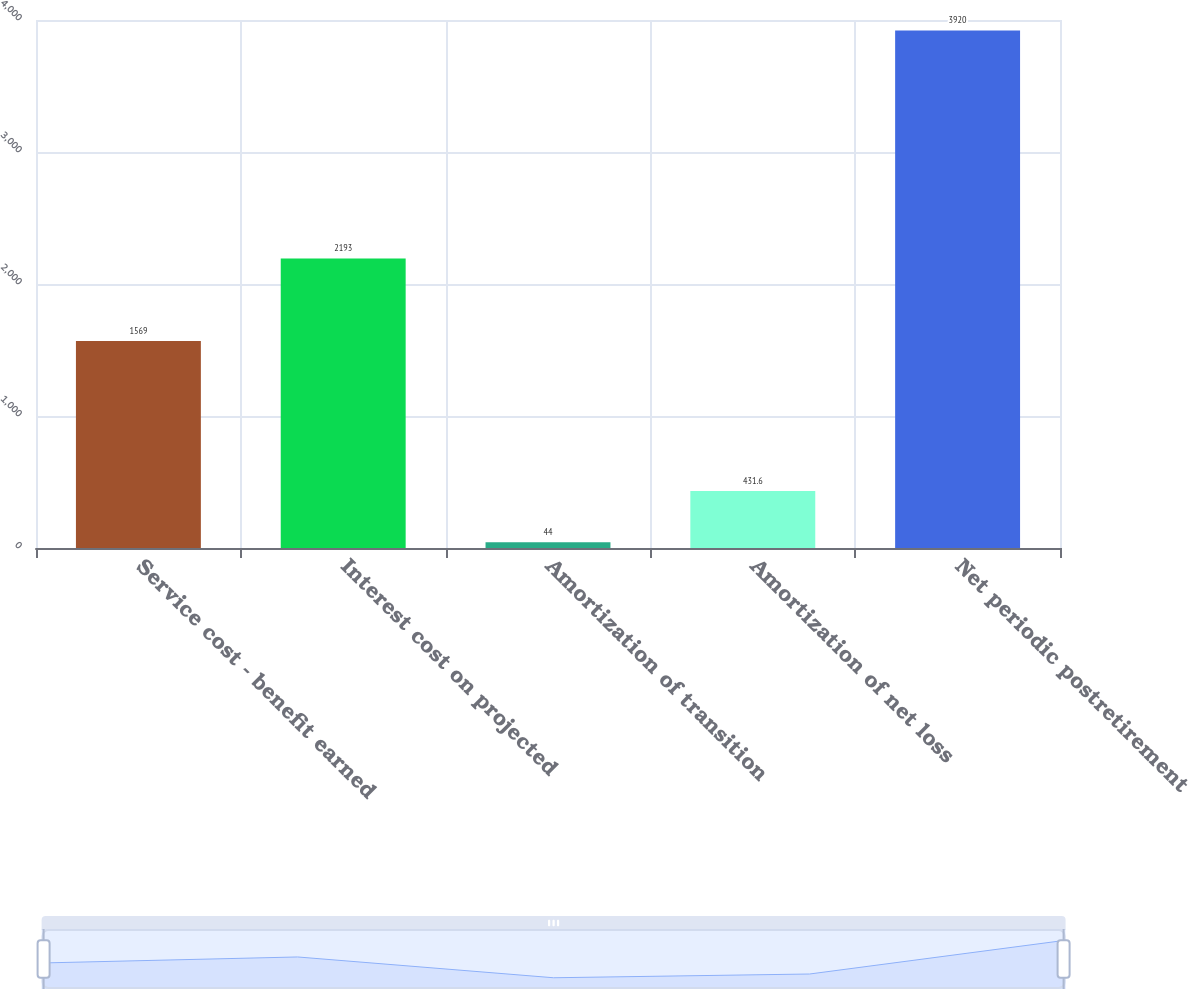Convert chart. <chart><loc_0><loc_0><loc_500><loc_500><bar_chart><fcel>Service cost - benefit earned<fcel>Interest cost on projected<fcel>Amortization of transition<fcel>Amortization of net loss<fcel>Net periodic postretirement<nl><fcel>1569<fcel>2193<fcel>44<fcel>431.6<fcel>3920<nl></chart> 